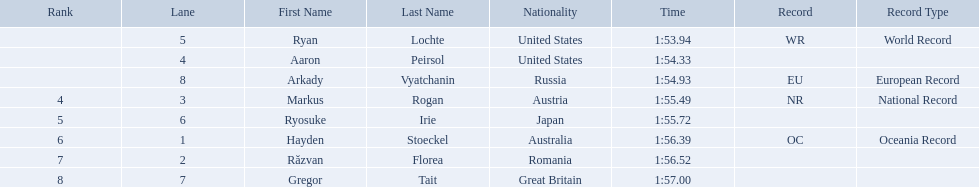Who participated in the event? Ryan Lochte, Aaron Peirsol, Arkady Vyatchanin, Markus Rogan, Ryosuke Irie, Hayden Stoeckel, Răzvan Florea, Gregor Tait. What was the finishing time of each athlete? 1:53.94, 1:54.33, 1:54.93, 1:55.49, 1:55.72, 1:56.39, 1:56.52, 1:57.00. How about just ryosuke irie? 1:55.72. 